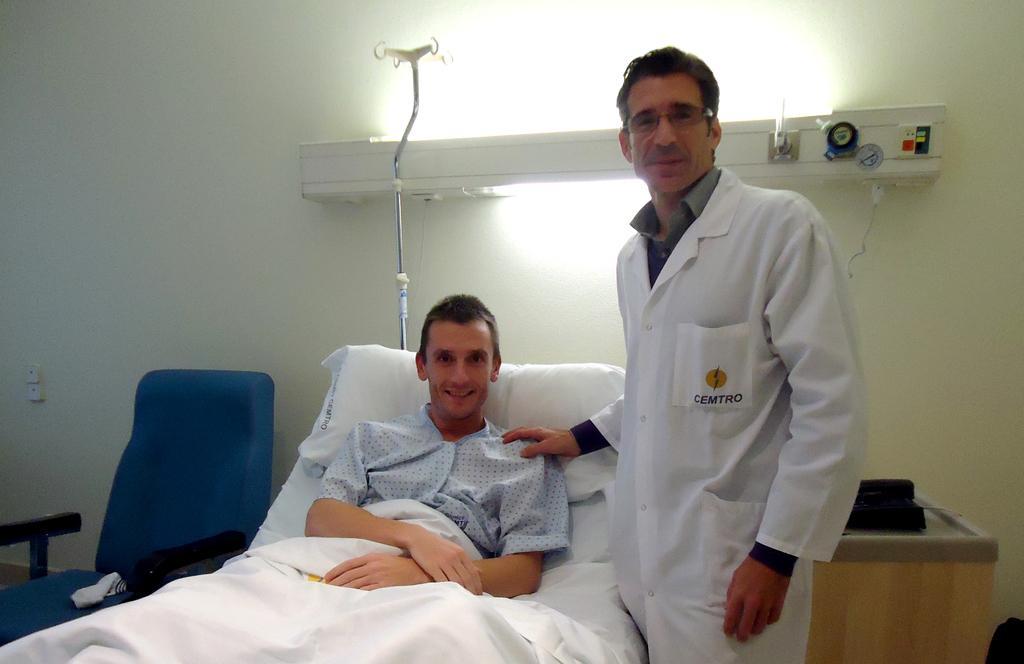Could you give a brief overview of what you see in this image? In this picture we can see a person sitting on the bed and smiling. There is a man standing on the floor. We can see a white object on a chair on the left side. There is a black object on a wooden desk on the right side. We can see a stand and other objects on a white surface. A light is visible in the background. 